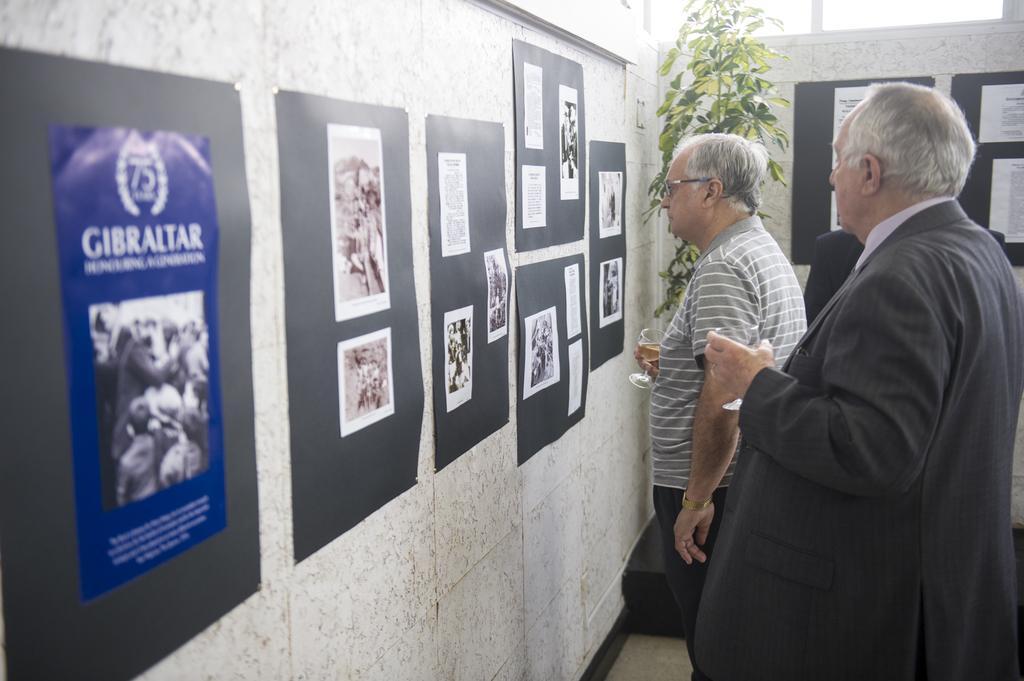Could you give a brief overview of what you see in this image? On the right side of the image we can see people standing and holding wine glasses and there are posters placed on the wall. In the background there is a plant and a wall. 